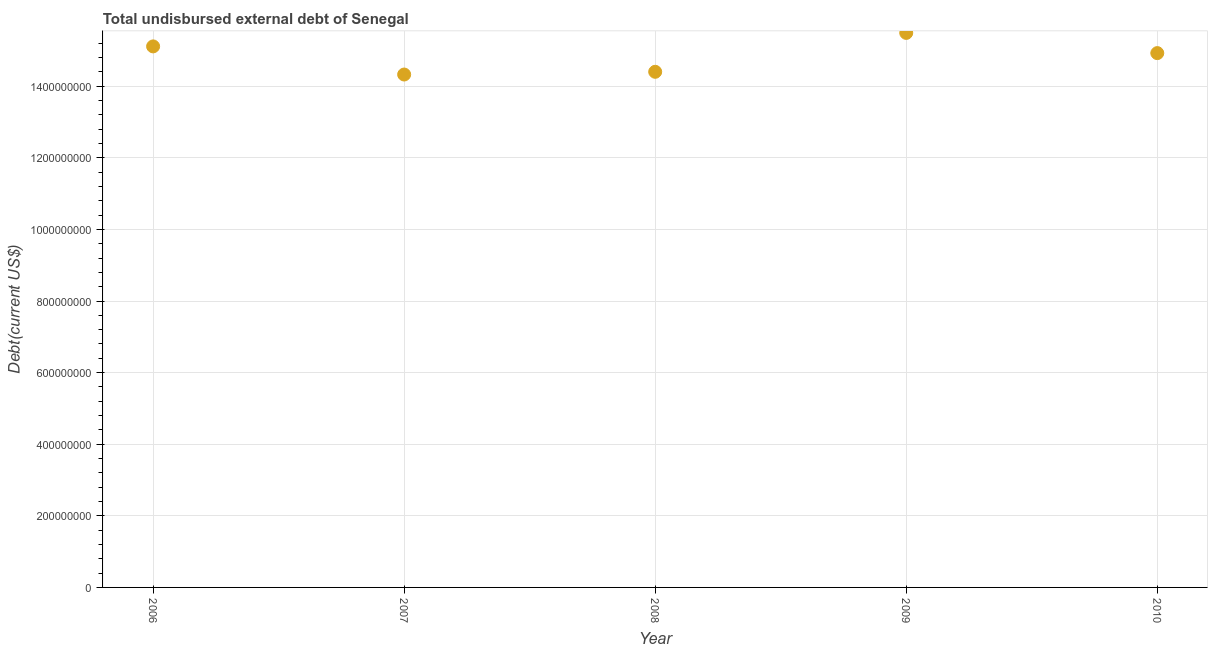What is the total debt in 2009?
Provide a short and direct response. 1.55e+09. Across all years, what is the maximum total debt?
Provide a succinct answer. 1.55e+09. Across all years, what is the minimum total debt?
Make the answer very short. 1.43e+09. What is the sum of the total debt?
Your answer should be compact. 7.43e+09. What is the difference between the total debt in 2008 and 2009?
Your answer should be compact. -1.09e+08. What is the average total debt per year?
Provide a succinct answer. 1.49e+09. What is the median total debt?
Your response must be concise. 1.49e+09. In how many years, is the total debt greater than 1400000000 US$?
Offer a very short reply. 5. Do a majority of the years between 2009 and 2006 (inclusive) have total debt greater than 1240000000 US$?
Give a very brief answer. Yes. What is the ratio of the total debt in 2007 to that in 2008?
Your answer should be very brief. 0.99. Is the total debt in 2006 less than that in 2008?
Keep it short and to the point. No. What is the difference between the highest and the second highest total debt?
Offer a very short reply. 3.77e+07. Is the sum of the total debt in 2007 and 2010 greater than the maximum total debt across all years?
Keep it short and to the point. Yes. What is the difference between the highest and the lowest total debt?
Keep it short and to the point. 1.16e+08. Does the total debt monotonically increase over the years?
Offer a very short reply. No. How many dotlines are there?
Give a very brief answer. 1. How many years are there in the graph?
Keep it short and to the point. 5. What is the difference between two consecutive major ticks on the Y-axis?
Your response must be concise. 2.00e+08. Are the values on the major ticks of Y-axis written in scientific E-notation?
Ensure brevity in your answer.  No. Does the graph contain any zero values?
Provide a succinct answer. No. What is the title of the graph?
Offer a very short reply. Total undisbursed external debt of Senegal. What is the label or title of the X-axis?
Provide a succinct answer. Year. What is the label or title of the Y-axis?
Your response must be concise. Debt(current US$). What is the Debt(current US$) in 2006?
Provide a succinct answer. 1.51e+09. What is the Debt(current US$) in 2007?
Keep it short and to the point. 1.43e+09. What is the Debt(current US$) in 2008?
Offer a terse response. 1.44e+09. What is the Debt(current US$) in 2009?
Keep it short and to the point. 1.55e+09. What is the Debt(current US$) in 2010?
Provide a succinct answer. 1.49e+09. What is the difference between the Debt(current US$) in 2006 and 2007?
Provide a short and direct response. 7.86e+07. What is the difference between the Debt(current US$) in 2006 and 2008?
Offer a terse response. 7.10e+07. What is the difference between the Debt(current US$) in 2006 and 2009?
Offer a terse response. -3.77e+07. What is the difference between the Debt(current US$) in 2006 and 2010?
Your response must be concise. 1.87e+07. What is the difference between the Debt(current US$) in 2007 and 2008?
Provide a short and direct response. -7.61e+06. What is the difference between the Debt(current US$) in 2007 and 2009?
Offer a very short reply. -1.16e+08. What is the difference between the Debt(current US$) in 2007 and 2010?
Make the answer very short. -5.98e+07. What is the difference between the Debt(current US$) in 2008 and 2009?
Offer a terse response. -1.09e+08. What is the difference between the Debt(current US$) in 2008 and 2010?
Your response must be concise. -5.22e+07. What is the difference between the Debt(current US$) in 2009 and 2010?
Provide a succinct answer. 5.64e+07. What is the ratio of the Debt(current US$) in 2006 to that in 2007?
Give a very brief answer. 1.05. What is the ratio of the Debt(current US$) in 2006 to that in 2008?
Your answer should be very brief. 1.05. What is the ratio of the Debt(current US$) in 2006 to that in 2009?
Ensure brevity in your answer.  0.98. What is the ratio of the Debt(current US$) in 2007 to that in 2009?
Ensure brevity in your answer.  0.93. What is the ratio of the Debt(current US$) in 2007 to that in 2010?
Keep it short and to the point. 0.96. What is the ratio of the Debt(current US$) in 2008 to that in 2010?
Give a very brief answer. 0.96. What is the ratio of the Debt(current US$) in 2009 to that in 2010?
Keep it short and to the point. 1.04. 